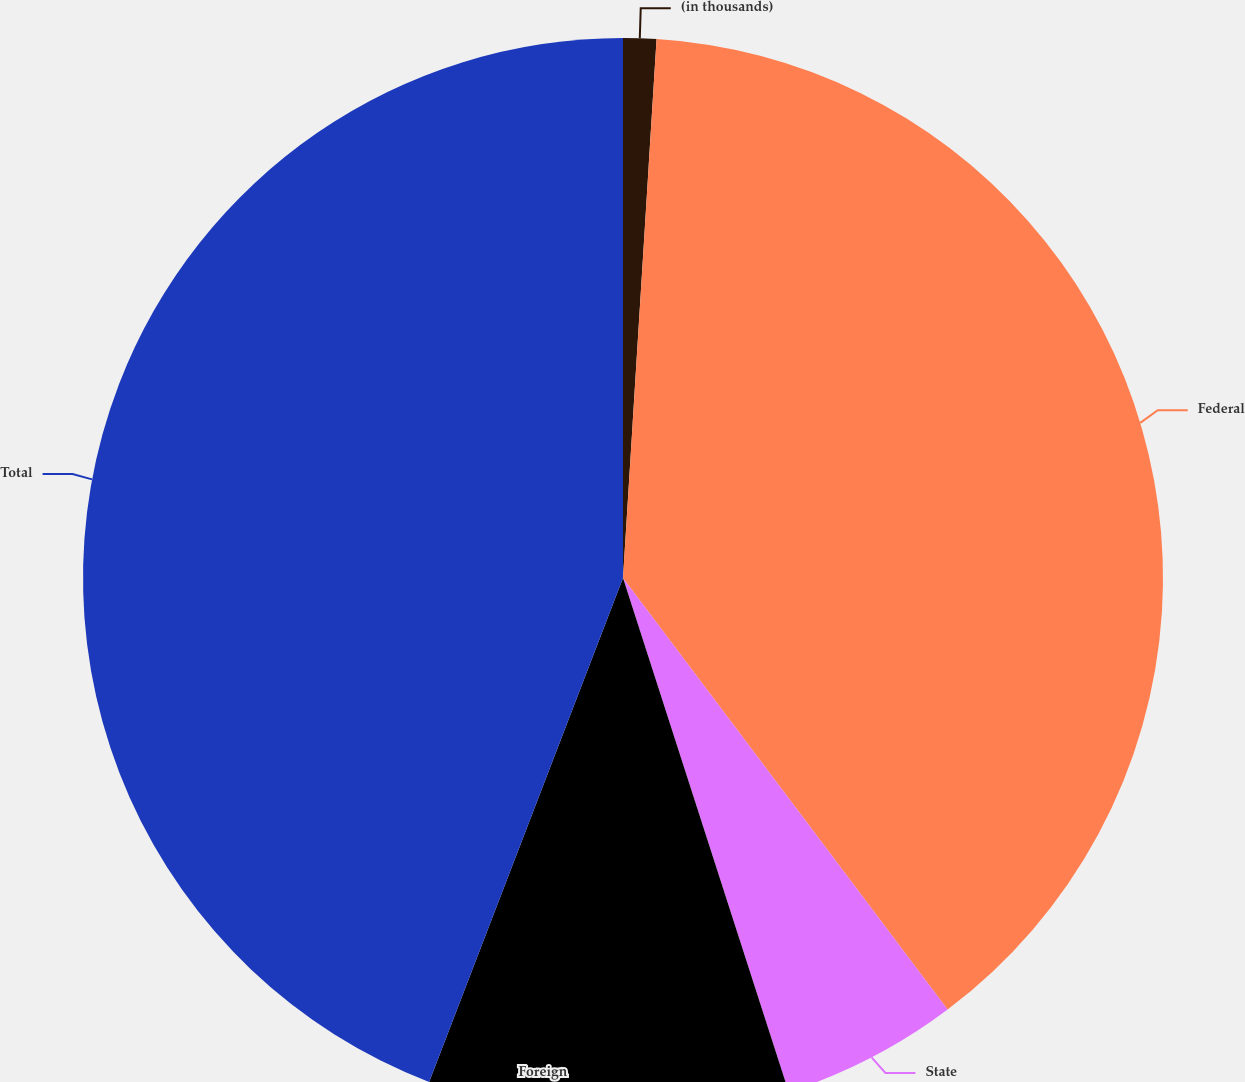Convert chart. <chart><loc_0><loc_0><loc_500><loc_500><pie_chart><fcel>(in thousands)<fcel>Federal<fcel>State<fcel>Foreign<fcel>Total<nl><fcel>0.99%<fcel>38.75%<fcel>5.3%<fcel>10.81%<fcel>44.16%<nl></chart> 